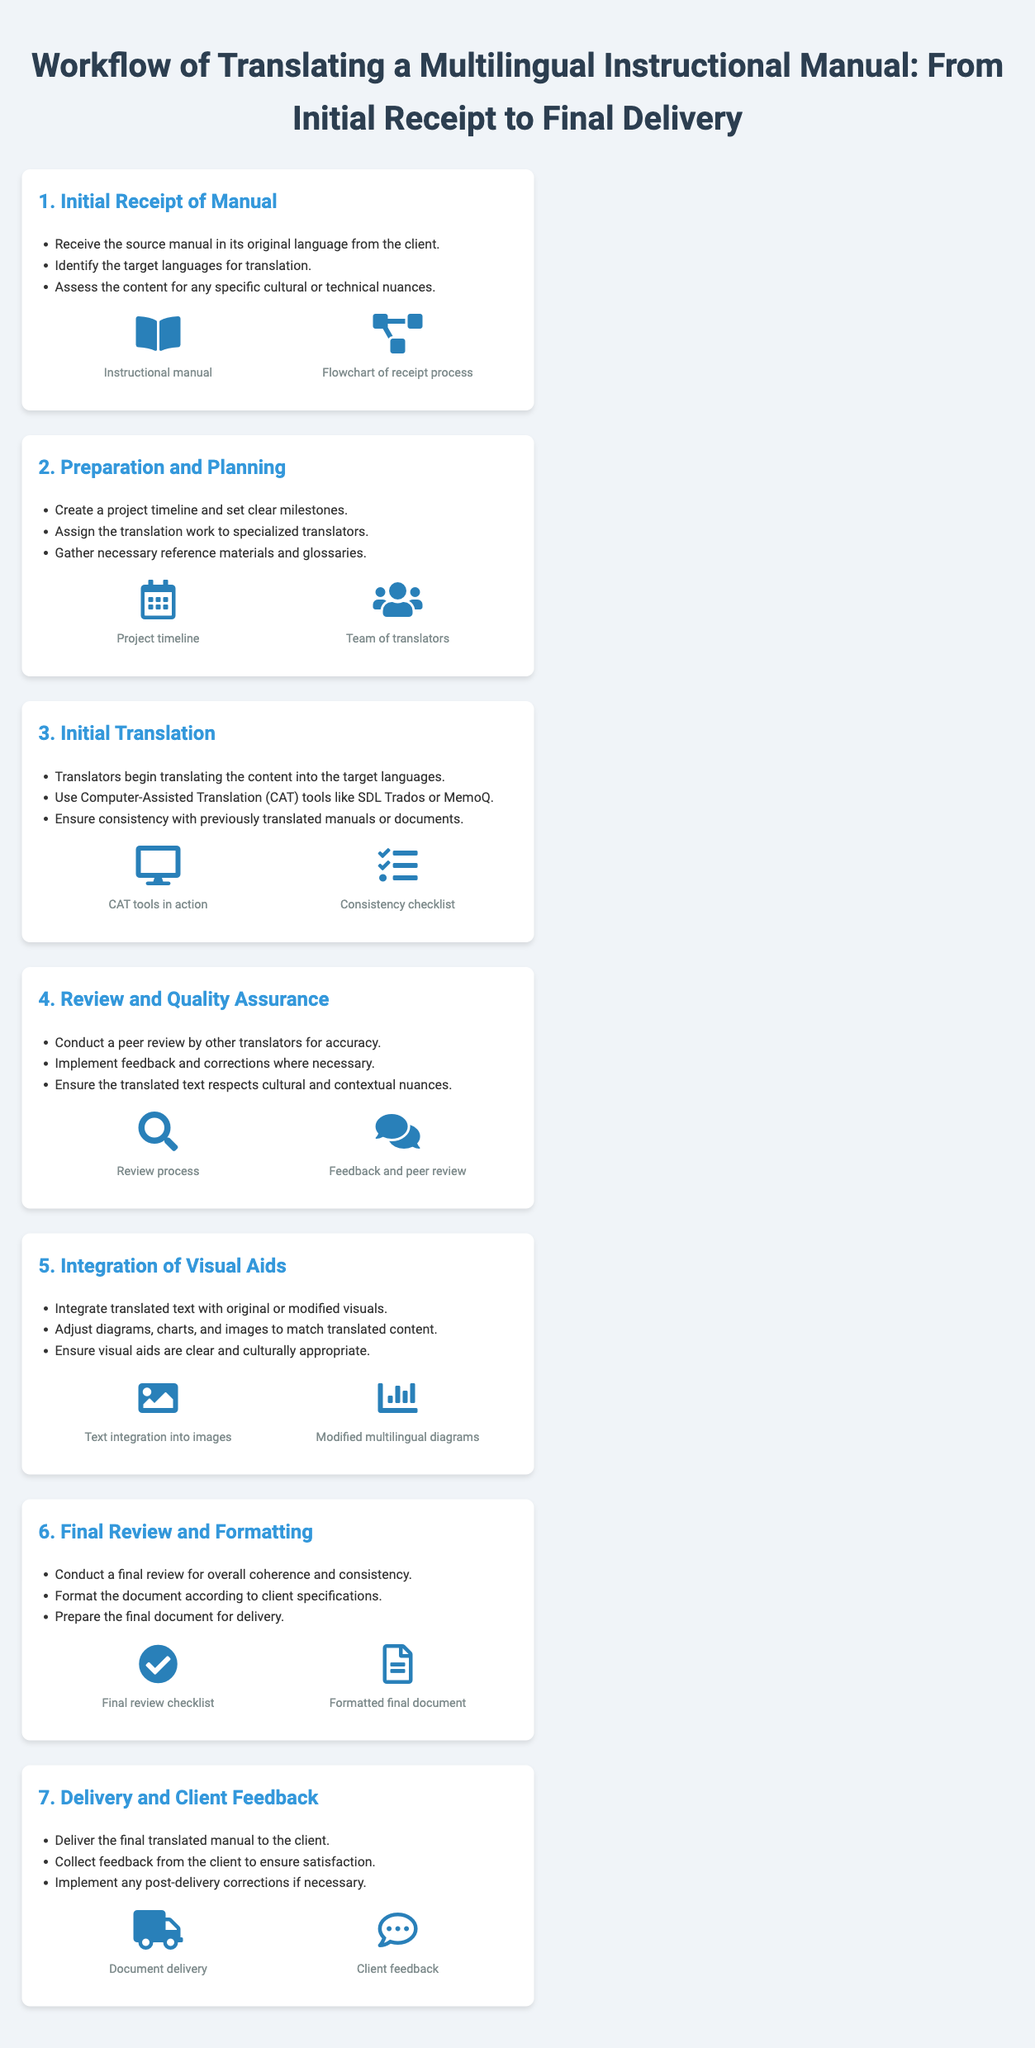what is the first step in the workflow? The first step is titled "Initial Receipt of Manual," which describes the initial actions after receiving the manual from the client.
Answer: Initial Receipt of Manual how many target languages should be identified? The document indicates that identifying target languages is part of the initial receipt step but does not specify a number; it varies based on client needs.
Answer: Varies what tool is recommended for initial translation? The document mentions using Computer-Assisted Translation (CAT) tools for the initial translation process.
Answer: CAT tools how many visuals are included in the "Integration of Visual Aids" step? The "Integration of Visual Aids" step includes two visuals related to text integration and modified diagrams.
Answer: Two what is conducted in the "Final Review and Formatting" step? The document states that a final review for coherence and consistency is conducted in this step.
Answer: Final review what is the main purpose of the “Delivery and Client Feedback” step? The purpose is to deliver the final translated manual and collect client feedback to ensure satisfaction.
Answer: Deliver manual and collect feedback who is involved in the "Preparation and Planning" step? The step involves assigning translation work to specialized translators as a key action.
Answer: Specialized translators what is a key activity in the "Review and Quality Assurance" step? A key activity is conducting a peer review by other translators for accuracy.
Answer: Peer review 